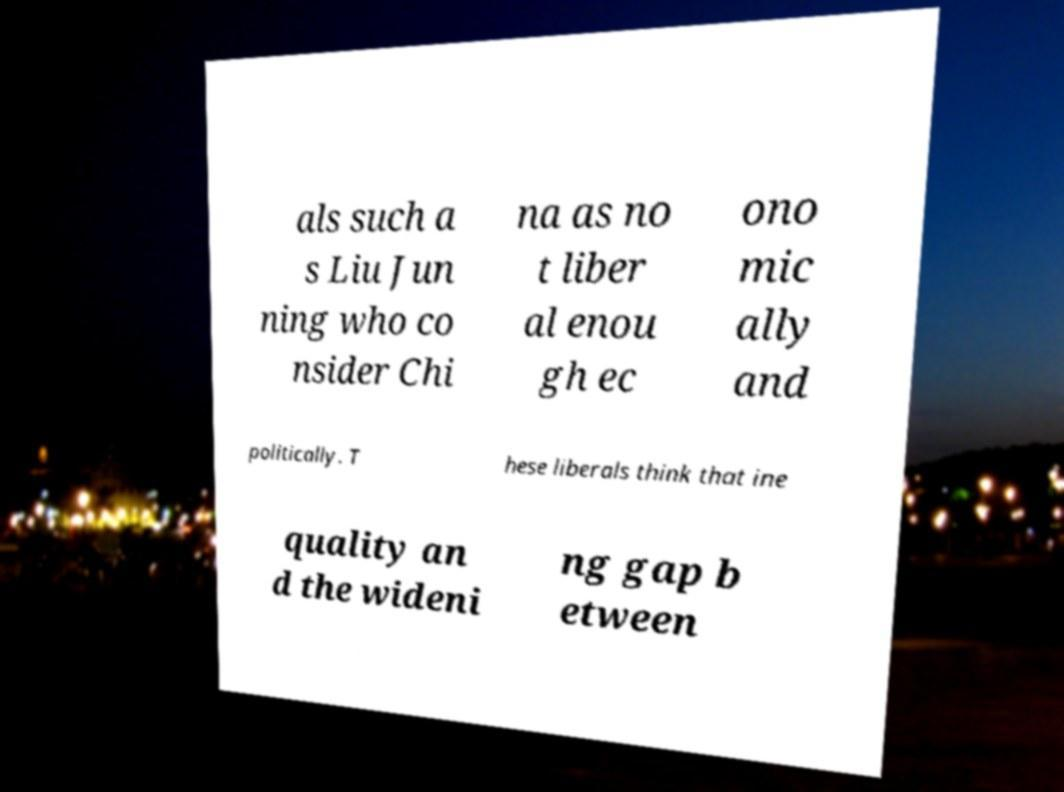I need the written content from this picture converted into text. Can you do that? als such a s Liu Jun ning who co nsider Chi na as no t liber al enou gh ec ono mic ally and politically. T hese liberals think that ine quality an d the wideni ng gap b etween 